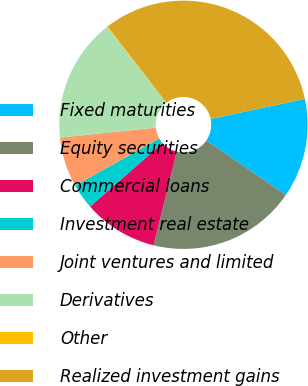Convert chart to OTSL. <chart><loc_0><loc_0><loc_500><loc_500><pie_chart><fcel>Fixed maturities<fcel>Equity securities<fcel>Commercial loans<fcel>Investment real estate<fcel>Joint ventures and limited<fcel>Derivatives<fcel>Other<fcel>Realized investment gains<nl><fcel>12.9%<fcel>19.3%<fcel>9.7%<fcel>3.29%<fcel>6.5%<fcel>16.1%<fcel>0.09%<fcel>32.11%<nl></chart> 